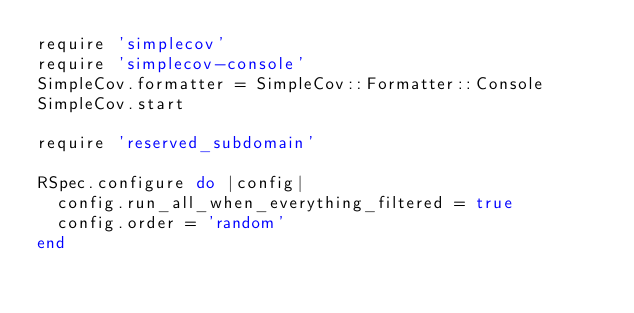<code> <loc_0><loc_0><loc_500><loc_500><_Ruby_>require 'simplecov'
require 'simplecov-console'
SimpleCov.formatter = SimpleCov::Formatter::Console
SimpleCov.start

require 'reserved_subdomain'

RSpec.configure do |config|
  config.run_all_when_everything_filtered = true
  config.order = 'random'
end
</code> 